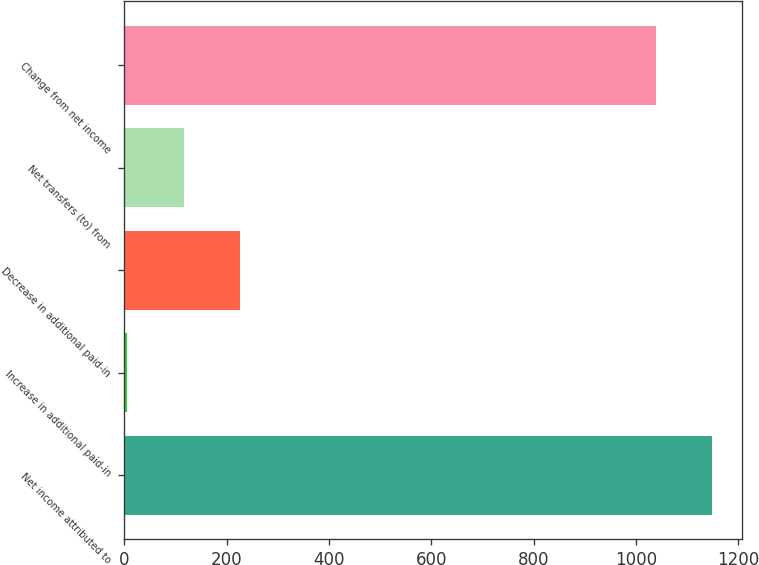Convert chart. <chart><loc_0><loc_0><loc_500><loc_500><bar_chart><fcel>Net income attributed to<fcel>Increase in additional paid-in<fcel>Decrease in additional paid-in<fcel>Net transfers (to) from<fcel>Change from net income<nl><fcel>1149.27<fcel>6.3<fcel>225.84<fcel>116.07<fcel>1039.5<nl></chart> 